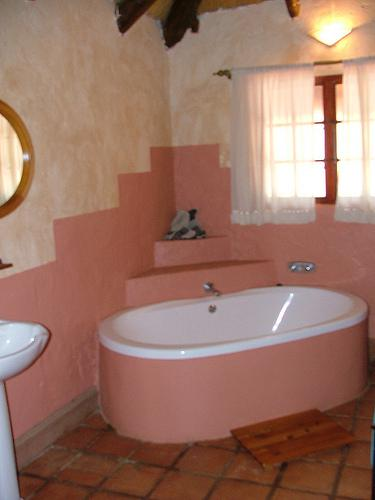Question: who is in the picture?
Choices:
A. No one.
B. A man.
C. Two men.
D. A woman.
Answer with the letter. Answer: A Question: where was the picture taken?
Choices:
A. In a bedroom.
B. In the living room.
C. In a kitchen.
D. In a bathroom.
Answer with the letter. Answer: D Question: why was the picture taken?
Choices:
A. To capture the tub.
B. To capture the sink.
C. To capture the tile.
D. To capture the mirror.
Answer with the letter. Answer: A Question: what color is the tub?
Choices:
A. Black and gold.
B. White and pink.
C. Red and blue.
D. Yellow and tan.
Answer with the letter. Answer: B Question: when was the picture taken?
Choices:
A. At sunset.
B. In the daytime.
C. At night.
D. Many years ago.
Answer with the letter. Answer: B 